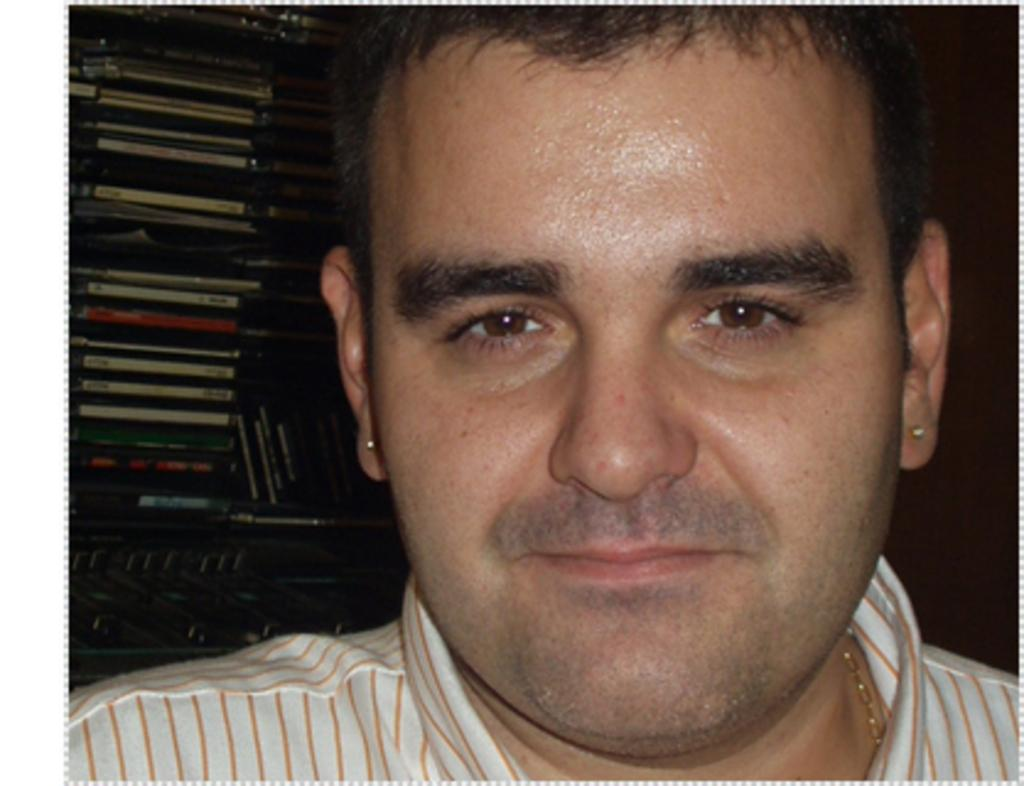Who is present in the image? There is a man in the image. What is the man wearing? The man is wearing a shirt and a locket. What is the man's facial expression? The man is smiling. Where is the man sitting in relation to the rack? The man is sitting near a rack. What can be found on the rack? There are many books on the rack. What type of soap is the man using in the image? There is no soap present in the image; the man is wearing a shirt and a locket, and he is sitting near a rack with many books. 